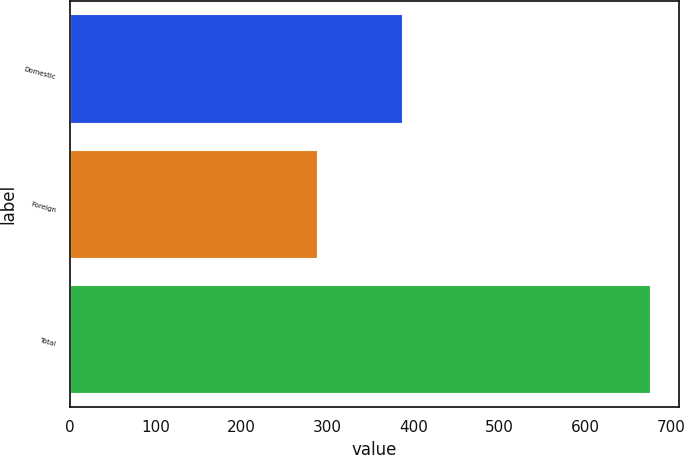Convert chart. <chart><loc_0><loc_0><loc_500><loc_500><bar_chart><fcel>Domestic<fcel>Foreign<fcel>Total<nl><fcel>386.9<fcel>287.9<fcel>674.8<nl></chart> 